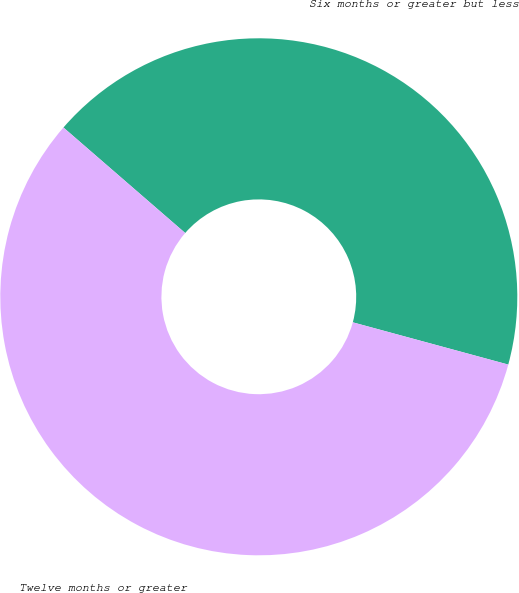<chart> <loc_0><loc_0><loc_500><loc_500><pie_chart><fcel>Six months or greater but less<fcel>Twelve months or greater<nl><fcel>42.86%<fcel>57.14%<nl></chart> 